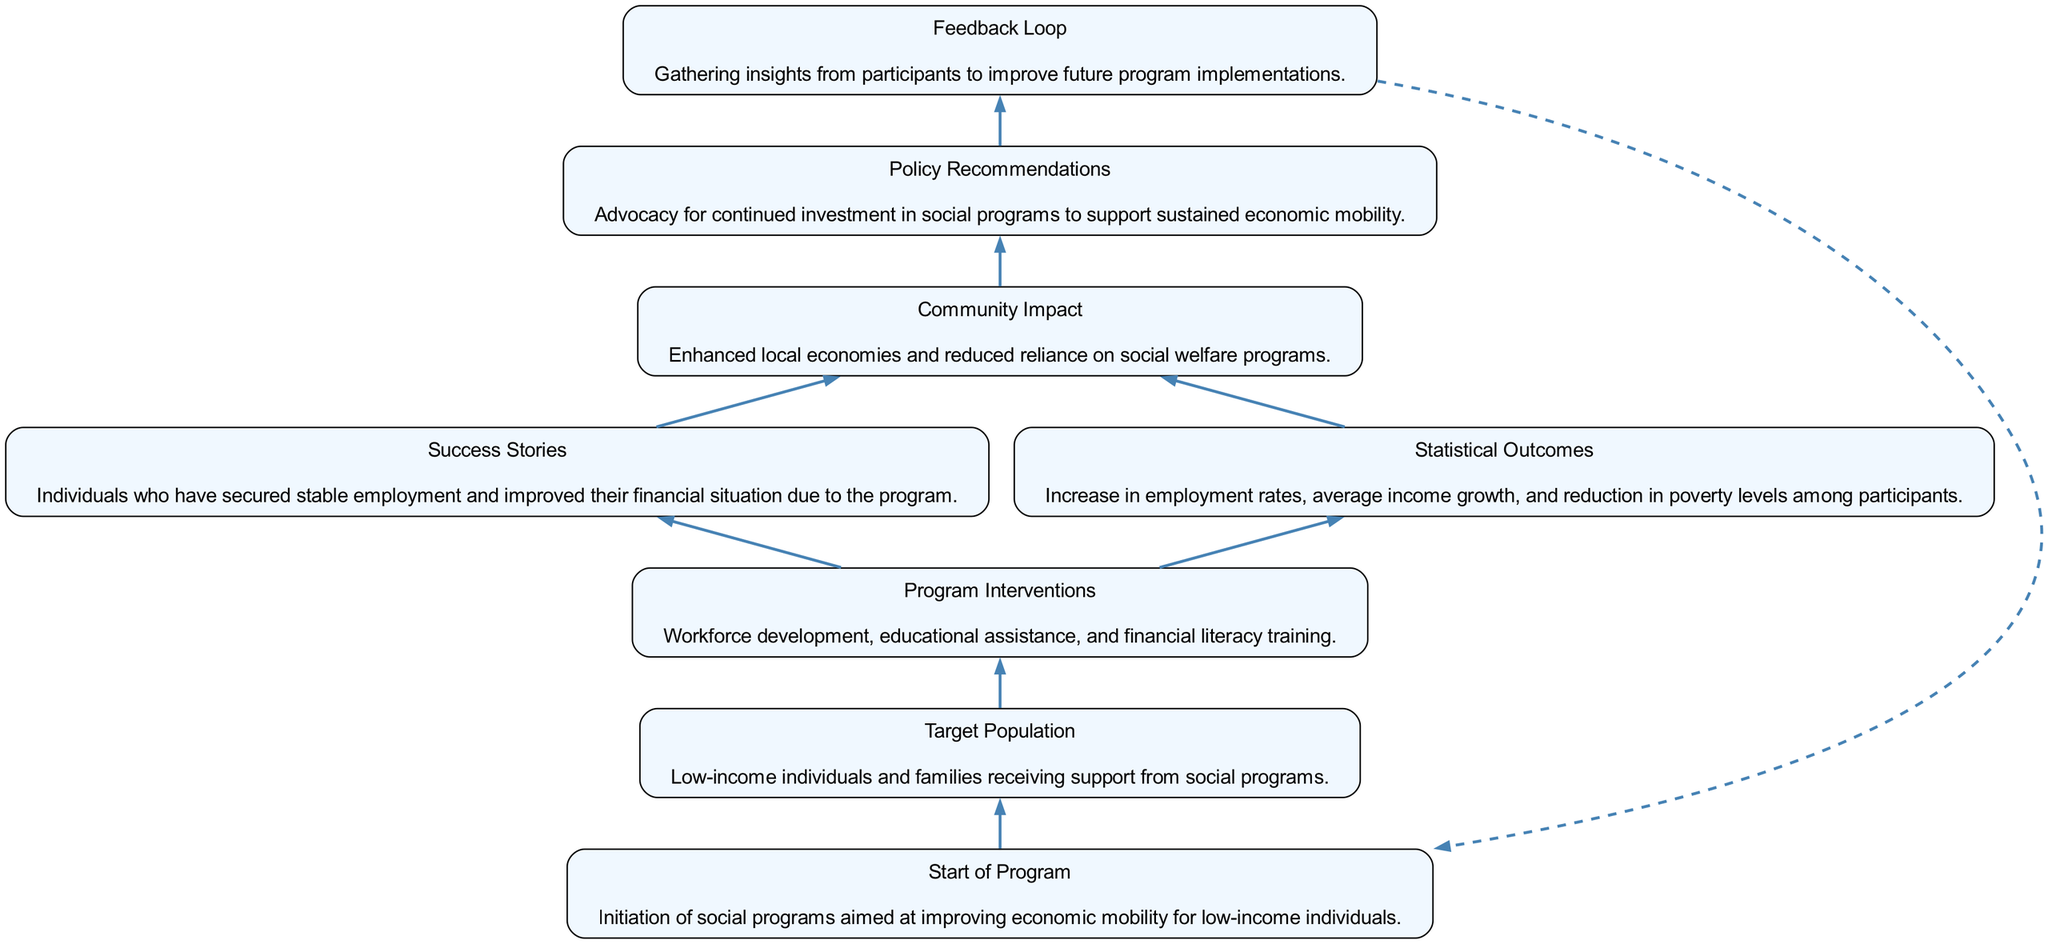What is the first node in the flow chart? The first node is labeled "Start of Program," which indicates the initiation of the social programs. Since the chart flows from bottom to top, this is at the beginning of the diagram.
Answer: Start of Program Which node describes the population targeted by the programs? The node labeled "Target Population" specifically describes the low-income individuals and families that are the focus of the social programs.
Answer: Target Population How many program interventions are mentioned in the diagram? The node labeled "Program Interventions" lists three specific types of interventions: workforce development, educational assistance, and financial literacy training. Therefore, the count is three.
Answer: 3 What is the last outcome mentioned in the flow chart? The last node in the flow chart is labeled "Policy Recommendations," which indicates the advocacy for continued investment in social programs. Thus, this is the final outcome articulated.
Answer: Policy Recommendations What relationship exists between "Success Stories" and "Statistical Outcomes"? The flow from "Success Stories" and "Statistical Outcomes" connects to the "Community Impact" node, suggesting that these successes and statistical improvements enhance the community's economic situation. Hence, both lead towards a common impact.
Answer: Both contribute to Community Impact How many edges connect to the "Community Impact" node? The "Community Impact" node has two incoming edges: one from "Success Stories" and one from "Statistical Outcomes." This indicates there are two connections leading to this node.
Answer: 2 What element is influenced by participant feedback? The "Feedback Loop" node indicates that participant insights are gathered to improve future program implementations, showing that feedback directly influences program adjustments.
Answer: Feedback Loop What is the role of "Program Interventions" in the flow chart? The "Program Interventions" node is a crucial element that connects to two outcome nodes: "Success Stories" and "Statistical Outcomes," indicating their function is to instigate these positive results for the target population.
Answer: To instigate Success Stories and Statistical Outcomes What follows after "Community Impact"? The "Policy Recommendations" node follows after "Community Impact," indicating that the positive economic changes inform policy recommendations for future social programs.
Answer: Policy Recommendations 